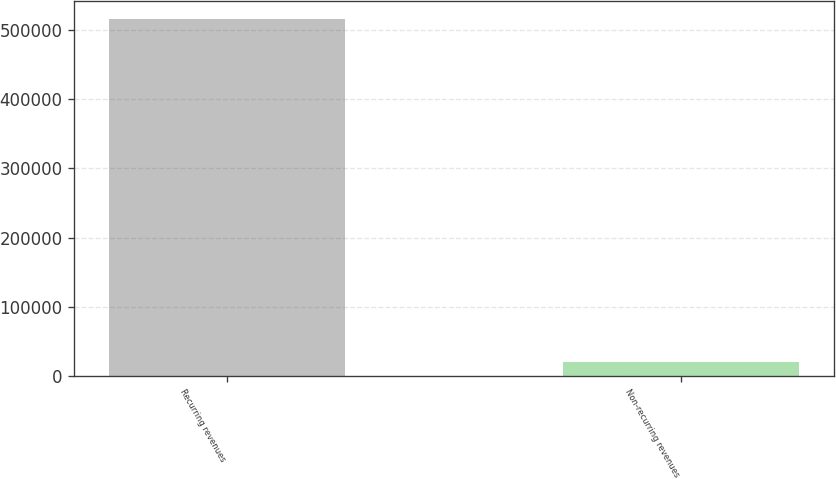Convert chart. <chart><loc_0><loc_0><loc_500><loc_500><bar_chart><fcel>Recurring revenues<fcel>Non-recurring revenues<nl><fcel>515780<fcel>19709<nl></chart> 